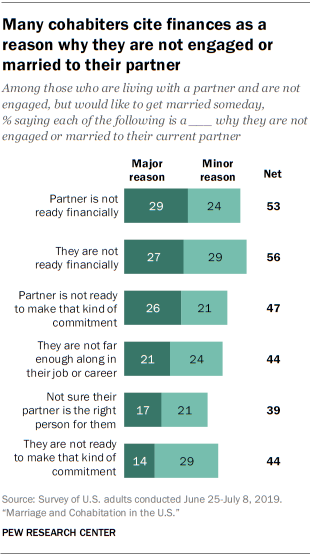Highlight a few significant elements in this photo. The value of the first Minor reason bar from the top is 24. The product of the medians of Major Reason Bars and Minor Reason Bars is 564. 